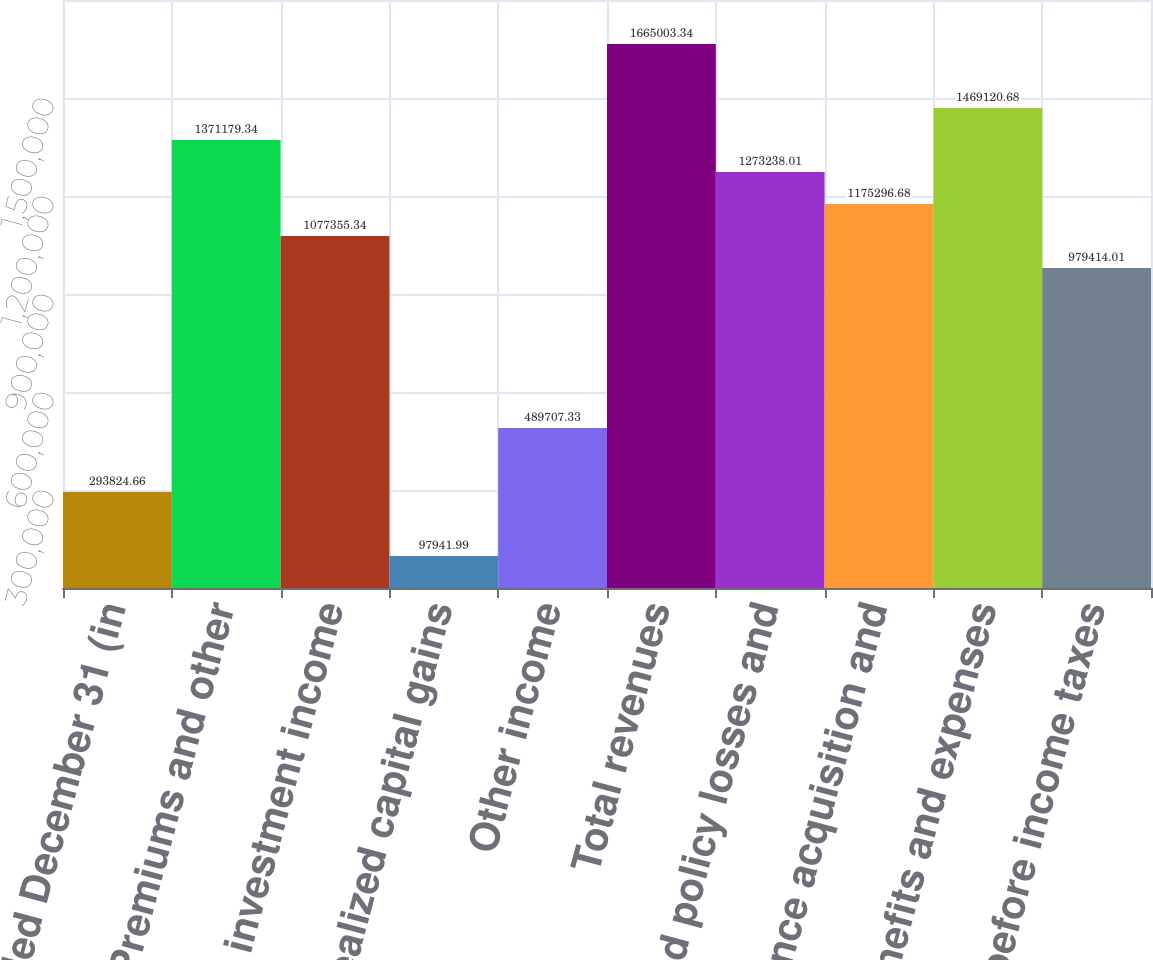Convert chart. <chart><loc_0><loc_0><loc_500><loc_500><bar_chart><fcel>Years Ended December 31 (in<fcel>Premiums and other<fcel>Net investment income<fcel>Realized capital gains<fcel>Other income<fcel>Total revenues<fcel>Incurred policy losses and<fcel>Insurance acquisition and<fcel>Total benefits and expenses<fcel>Income before income taxes<nl><fcel>293825<fcel>1.37118e+06<fcel>1.07736e+06<fcel>97942<fcel>489707<fcel>1.665e+06<fcel>1.27324e+06<fcel>1.1753e+06<fcel>1.46912e+06<fcel>979414<nl></chart> 